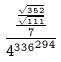Convert formula to latex. <formula><loc_0><loc_0><loc_500><loc_500>\frac { \frac { \frac { \sqrt { 3 5 2 } } { \sqrt { 1 1 1 } } } { 7 } } { { 4 ^ { 3 3 6 } } ^ { 2 9 4 } }</formula> 